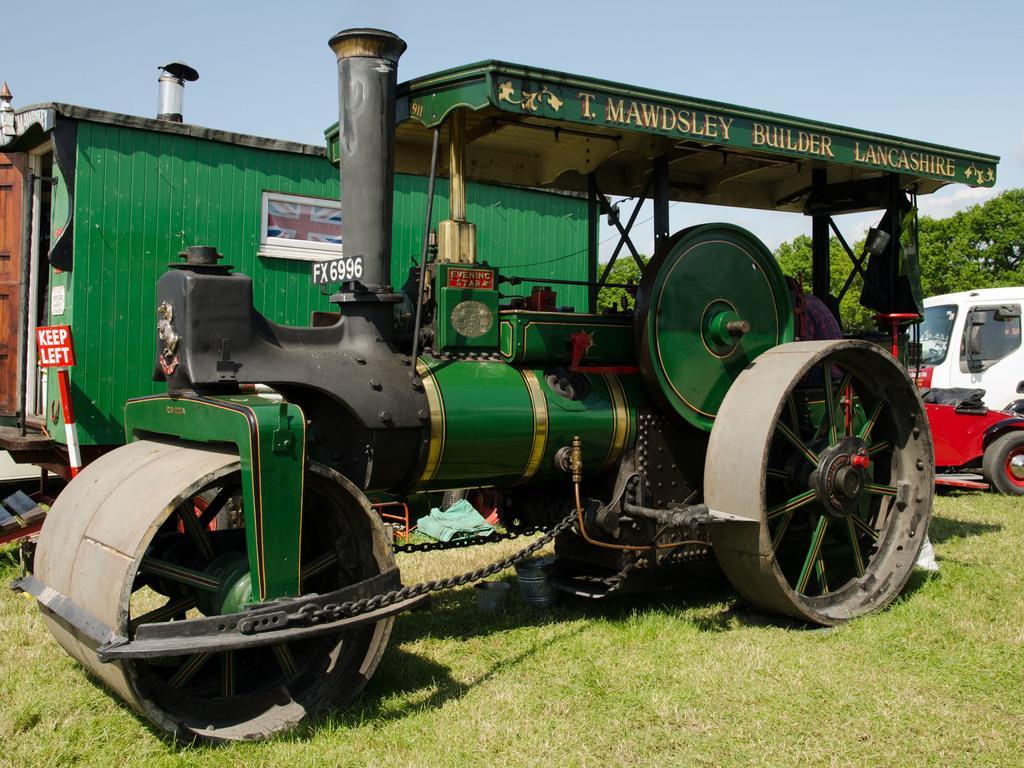Describe this image in one or two sentences. This is the picture of a place where we have two vehicles on the grass floor and around there are some trees. 